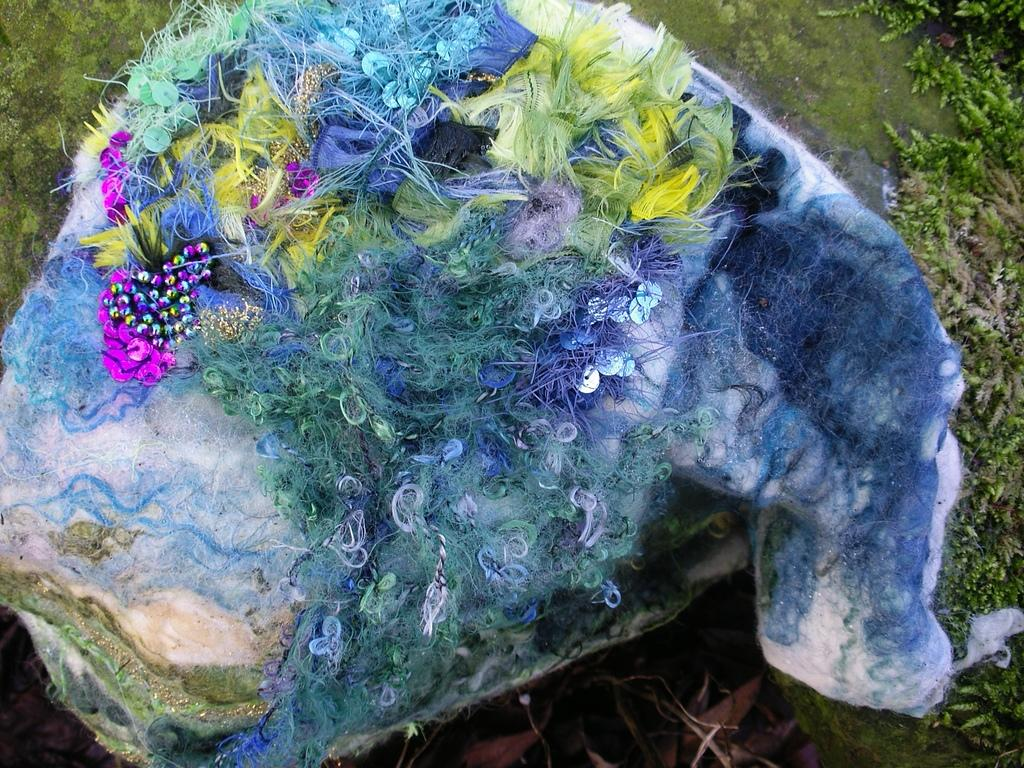What objects are present in the image? There are beads and an object with threads in the image. Can you describe the object with threads? The object with threads is not specified, but it has threads on it. What can be seen in the background of the image? There are plants in the background of the image. What type of attention is the beads receiving in the image? The beads are not receiving any specific type of attention in the image; they are simply present. What does the image smell like? The image does not have a smell, as it is a visual representation. 